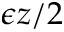<formula> <loc_0><loc_0><loc_500><loc_500>\epsilon z / 2</formula> 